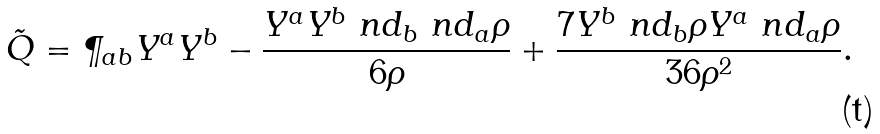Convert formula to latex. <formula><loc_0><loc_0><loc_500><loc_500>\tilde { Q } = \P _ { a b } Y ^ { a } Y ^ { b } - \frac { Y ^ { a } Y ^ { b } \ n d _ { b } \ n d _ { a } \rho } { 6 \rho } + \frac { 7 Y ^ { b } \ n d _ { b } \rho Y ^ { a } \ n d _ { a } \rho } { 3 6 \rho ^ { 2 } } .</formula> 